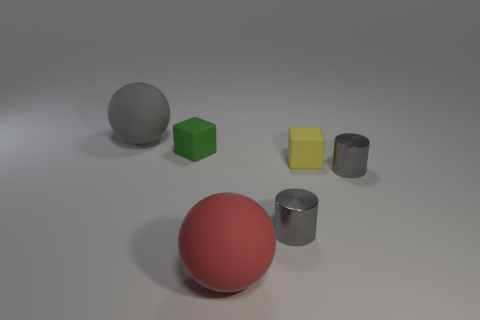Is there a large gray object made of the same material as the large red object?
Provide a succinct answer. Yes. The big gray matte object has what shape?
Make the answer very short. Sphere. What is the shape of the yellow rubber object right of the block that is left of the yellow matte cube?
Your answer should be compact. Cube. What number of other objects are the same shape as the big gray thing?
Offer a terse response. 1. What is the size of the red matte ball that is in front of the gray shiny cylinder on the left side of the yellow matte thing?
Offer a terse response. Large. Are there any green things?
Provide a short and direct response. Yes. What number of small yellow objects are left of the tiny cube in front of the tiny green matte block?
Make the answer very short. 0. There is a rubber object that is to the right of the red object; what is its shape?
Offer a very short reply. Cube. What is the material of the tiny gray cylinder that is on the left side of the gray shiny thing that is behind the small gray cylinder that is on the left side of the yellow rubber block?
Provide a short and direct response. Metal. What number of other things are the same size as the green matte block?
Your answer should be very brief. 3. 